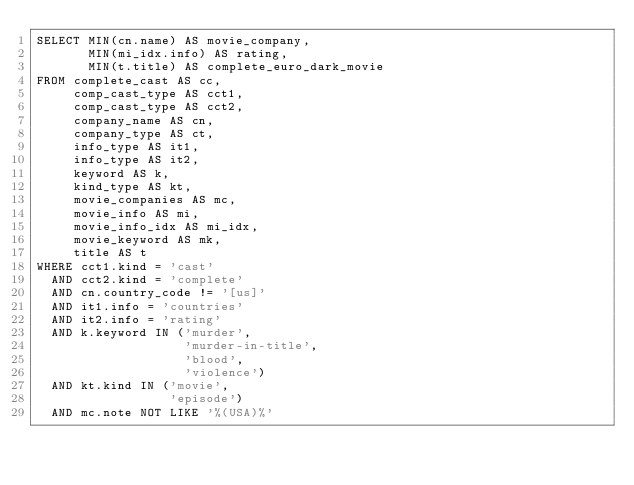Convert code to text. <code><loc_0><loc_0><loc_500><loc_500><_SQL_>SELECT MIN(cn.name) AS movie_company,
       MIN(mi_idx.info) AS rating,
       MIN(t.title) AS complete_euro_dark_movie
FROM complete_cast AS cc,
     comp_cast_type AS cct1,
     comp_cast_type AS cct2,
     company_name AS cn,
     company_type AS ct,
     info_type AS it1,
     info_type AS it2,
     keyword AS k,
     kind_type AS kt,
     movie_companies AS mc,
     movie_info AS mi,
     movie_info_idx AS mi_idx,
     movie_keyword AS mk,
     title AS t
WHERE cct1.kind = 'cast'
  AND cct2.kind = 'complete'
  AND cn.country_code != '[us]'
  AND it1.info = 'countries'
  AND it2.info = 'rating'
  AND k.keyword IN ('murder',
                    'murder-in-title',
                    'blood',
                    'violence')
  AND kt.kind IN ('movie',
                  'episode')
  AND mc.note NOT LIKE '%(USA)%'</code> 